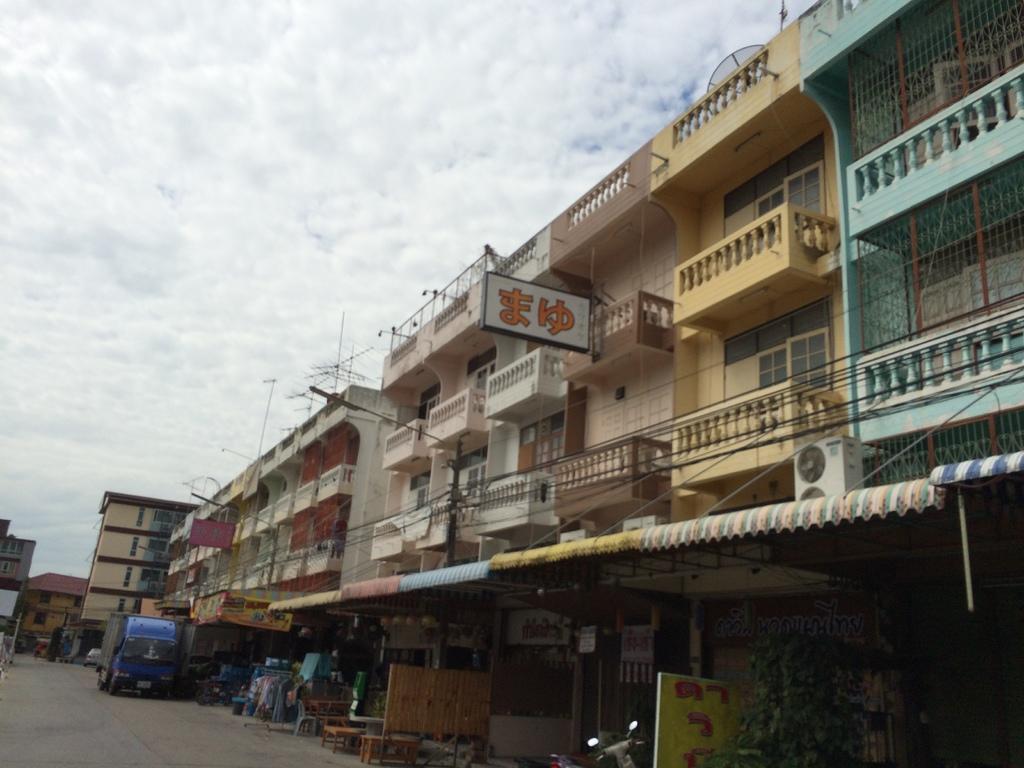Could you give a brief overview of what you see in this image? There is a bike and a truck present at the bottom of this image. We can see the buildings in the background and the cloudy sky at the top of this image. 